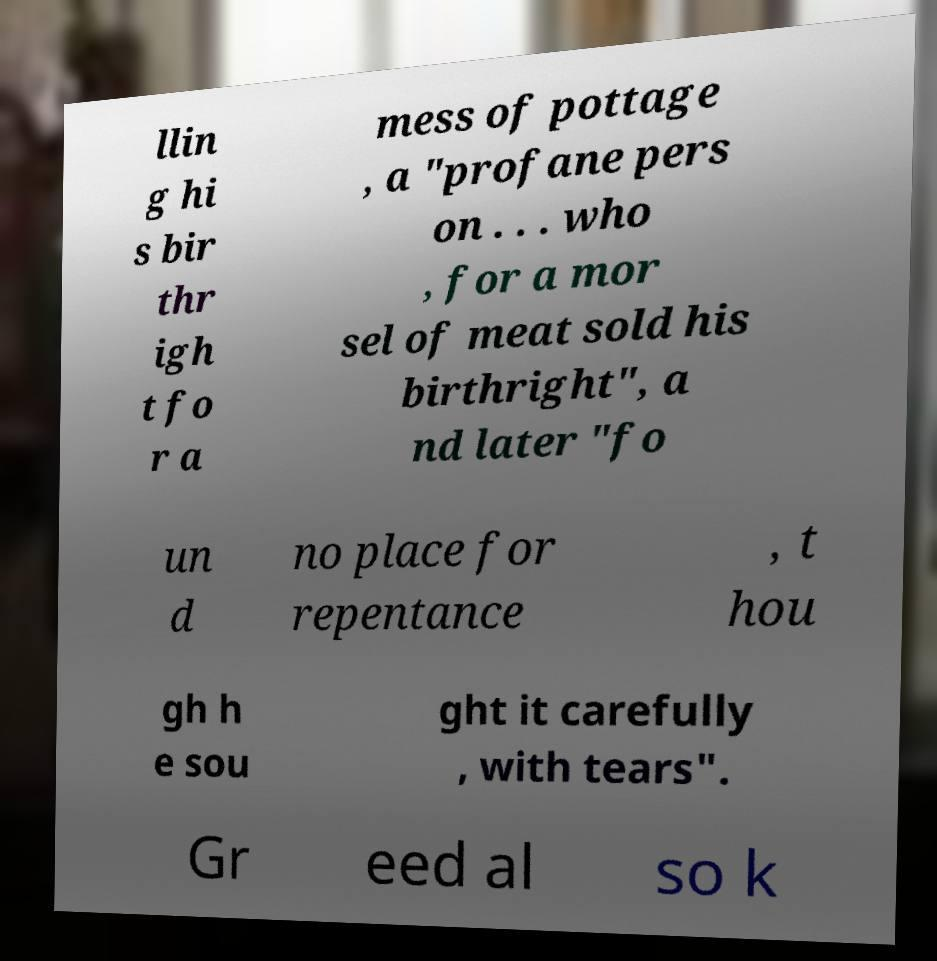For documentation purposes, I need the text within this image transcribed. Could you provide that? llin g hi s bir thr igh t fo r a mess of pottage , a "profane pers on . . . who , for a mor sel of meat sold his birthright", a nd later "fo un d no place for repentance , t hou gh h e sou ght it carefully , with tears". Gr eed al so k 